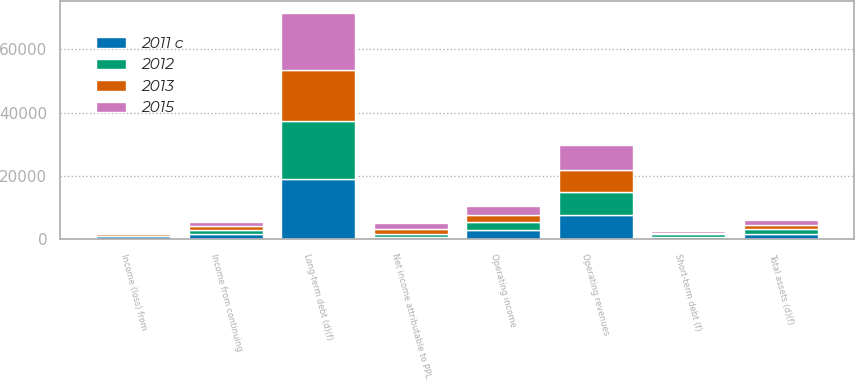<chart> <loc_0><loc_0><loc_500><loc_500><stacked_bar_chart><ecel><fcel>Operating revenues<fcel>Operating income<fcel>Income from continuing<fcel>Income (loss) from<fcel>Net income attributable to PPL<fcel>Total assets (d)(f)<fcel>Short-term debt (f)<fcel>Long-term debt (d)(f)<nl><fcel>2011 c<fcel>7669<fcel>2831<fcel>1603<fcel>921<fcel>682<fcel>1564.5<fcel>916<fcel>19048<nl><fcel>2015<fcel>7852<fcel>2867<fcel>1437<fcel>300<fcel>1737<fcel>1564.5<fcel>836<fcel>18054<nl><fcel>2012<fcel>7263<fcel>2561<fcel>1368<fcel>238<fcel>1130<fcel>1564.5<fcel>701<fcel>18269<nl><fcel>2013<fcel>6856<fcel>2228<fcel>1114<fcel>412<fcel>1526<fcel>1564.5<fcel>296<fcel>16120<nl></chart> 